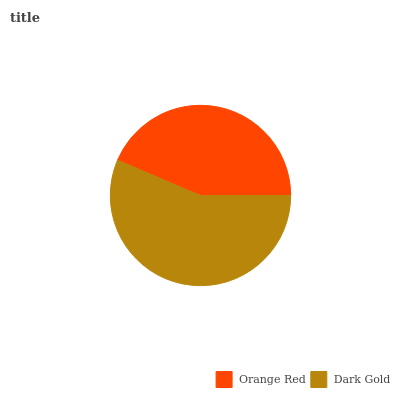Is Orange Red the minimum?
Answer yes or no. Yes. Is Dark Gold the maximum?
Answer yes or no. Yes. Is Dark Gold the minimum?
Answer yes or no. No. Is Dark Gold greater than Orange Red?
Answer yes or no. Yes. Is Orange Red less than Dark Gold?
Answer yes or no. Yes. Is Orange Red greater than Dark Gold?
Answer yes or no. No. Is Dark Gold less than Orange Red?
Answer yes or no. No. Is Dark Gold the high median?
Answer yes or no. Yes. Is Orange Red the low median?
Answer yes or no. Yes. Is Orange Red the high median?
Answer yes or no. No. Is Dark Gold the low median?
Answer yes or no. No. 